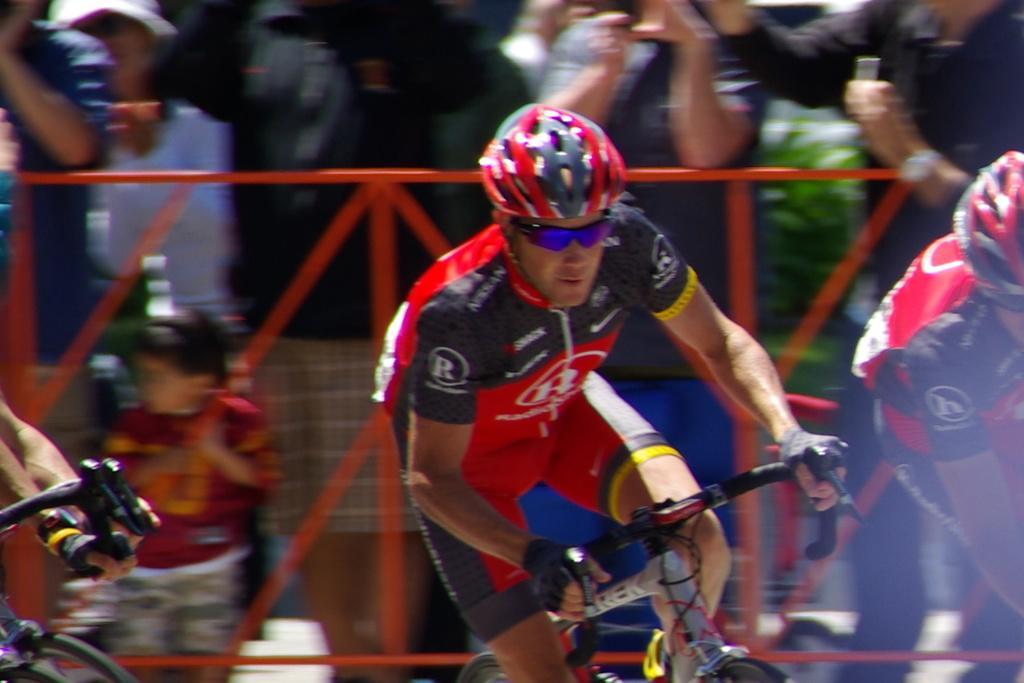Describe this image in one or two sentences. In the center of the image there is a person wearing a red color helmet and riding a bicycle. In the background of the image there are people standing. There is a red color fencing. 